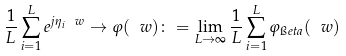<formula> <loc_0><loc_0><loc_500><loc_500>\frac { 1 } { L } \sum _ { i = 1 } ^ { L } e ^ { j \eta _ { i } \ w } \rightarrow \varphi ( \ w ) \colon = \lim _ { L \rightarrow \infty } \frac { 1 } { L } \sum _ { i = 1 } ^ { L } \varphi _ { \i e t a } ( \ w )</formula> 